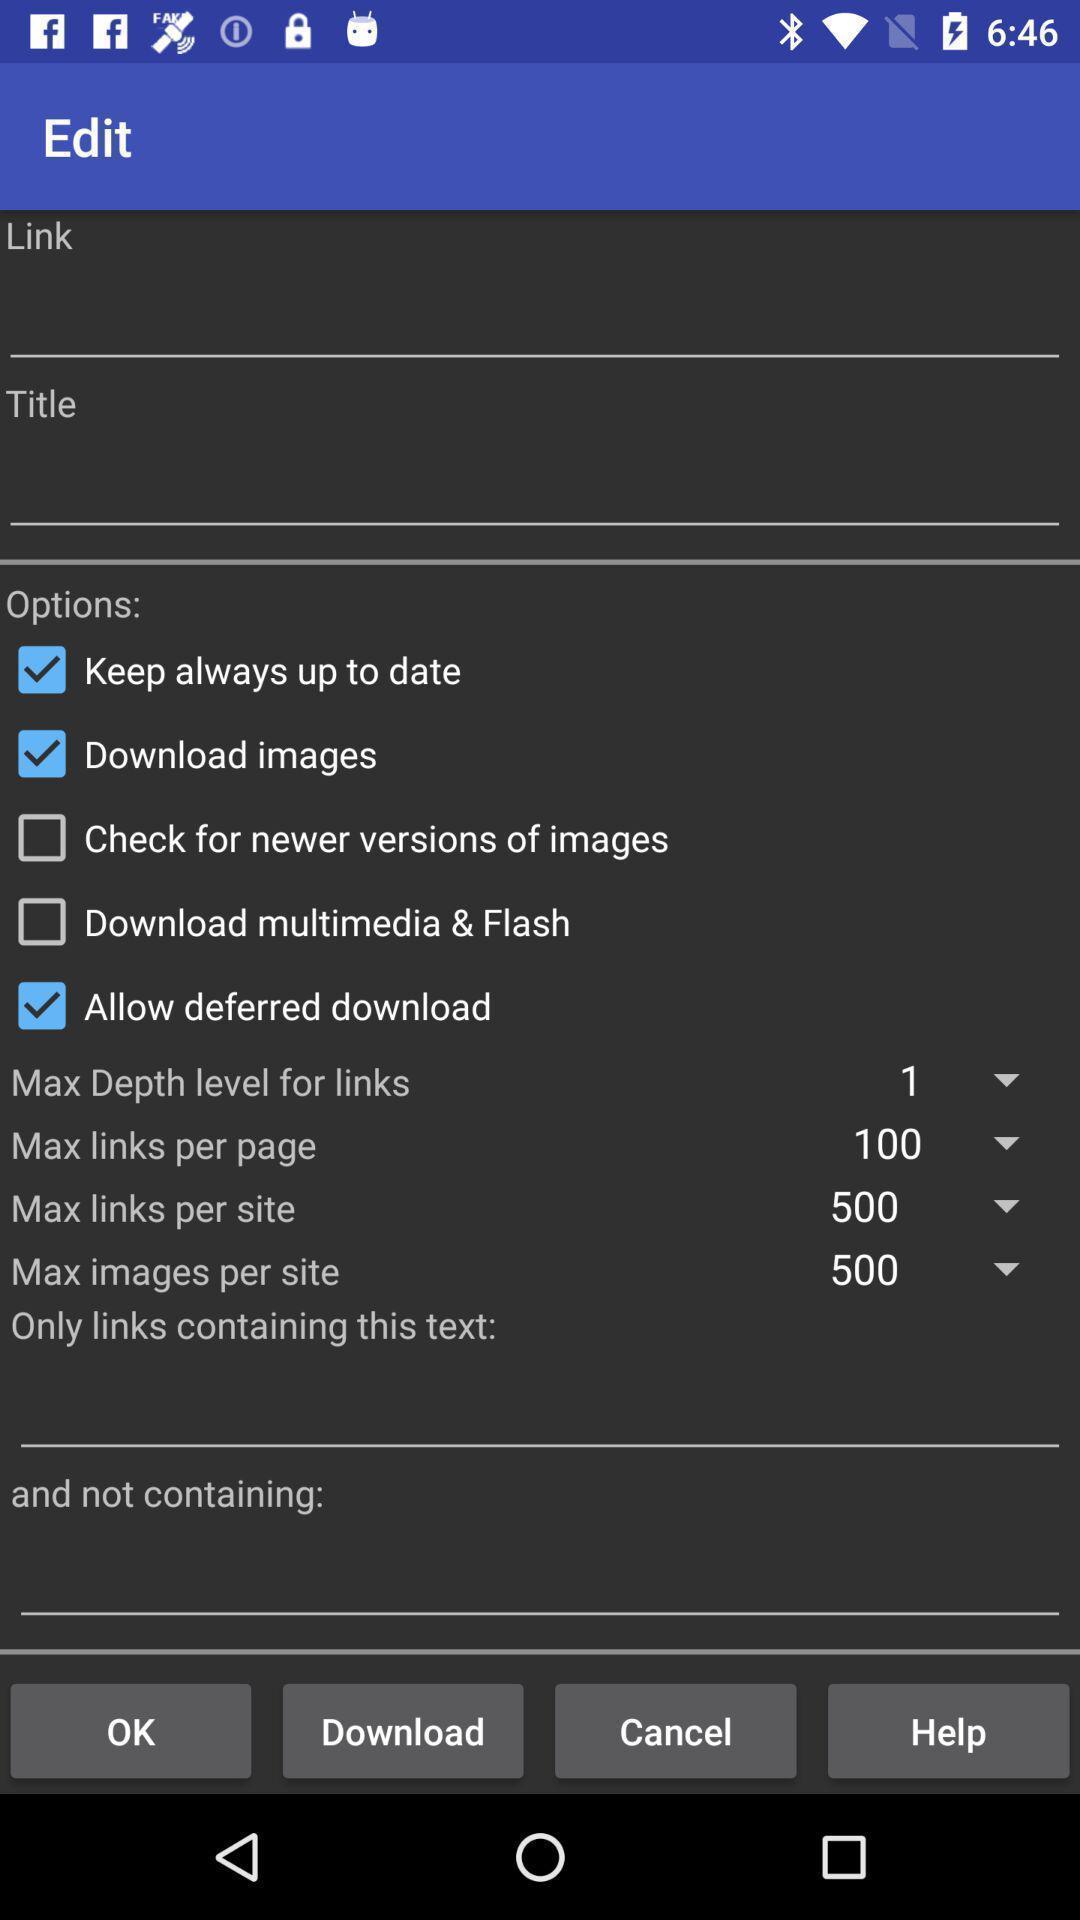Describe the content in this image. Page showing multiple options for web browsing app. 